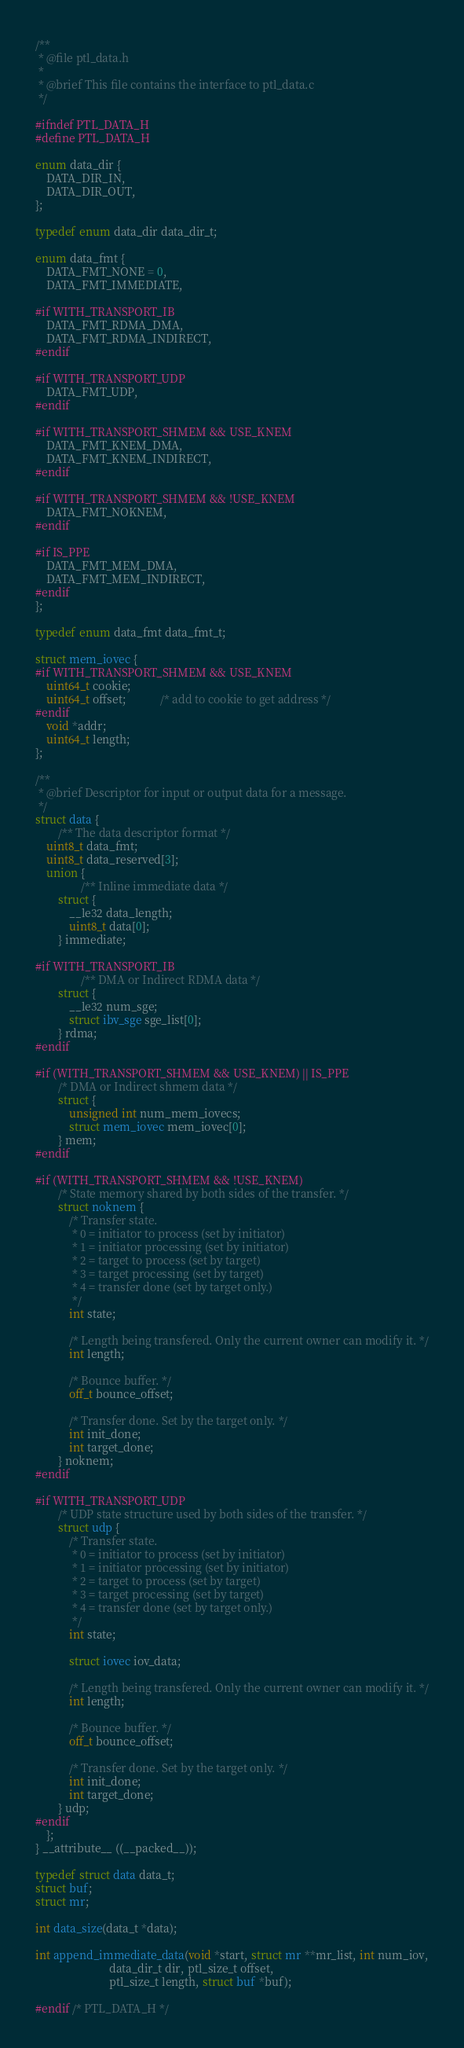Convert code to text. <code><loc_0><loc_0><loc_500><loc_500><_C_>/**
 * @file ptl_data.h
 *
 * @brief This file contains the interface to ptl_data.c
 */

#ifndef PTL_DATA_H
#define PTL_DATA_H

enum data_dir {
    DATA_DIR_IN,
    DATA_DIR_OUT,
};

typedef enum data_dir data_dir_t;

enum data_fmt {
    DATA_FMT_NONE = 0,
    DATA_FMT_IMMEDIATE,

#if WITH_TRANSPORT_IB
    DATA_FMT_RDMA_DMA,
    DATA_FMT_RDMA_INDIRECT,
#endif

#if WITH_TRANSPORT_UDP
    DATA_FMT_UDP,
#endif

#if WITH_TRANSPORT_SHMEM && USE_KNEM
    DATA_FMT_KNEM_DMA,
    DATA_FMT_KNEM_INDIRECT,
#endif

#if WITH_TRANSPORT_SHMEM && !USE_KNEM
    DATA_FMT_NOKNEM,
#endif

#if IS_PPE
    DATA_FMT_MEM_DMA,
    DATA_FMT_MEM_INDIRECT,
#endif
};

typedef enum data_fmt data_fmt_t;

struct mem_iovec {
#if WITH_TRANSPORT_SHMEM && USE_KNEM
    uint64_t cookie;
    uint64_t offset;            /* add to cookie to get address */
#endif
    void *addr;
    uint64_t length;
};

/**
 * @brief Descriptor for input or output data for a message.
 */
struct data {
        /** The data descriptor format */
    uint8_t data_fmt;
    uint8_t data_reserved[3];
    union {
                /** Inline immediate data */
        struct {
            __le32 data_length;
            uint8_t data[0];
        } immediate;

#if WITH_TRANSPORT_IB
                /** DMA or Indirect RDMA data */
        struct {
            __le32 num_sge;
            struct ibv_sge sge_list[0];
        } rdma;
#endif

#if (WITH_TRANSPORT_SHMEM && USE_KNEM) || IS_PPE
        /* DMA or Indirect shmem data */
        struct {
            unsigned int num_mem_iovecs;
            struct mem_iovec mem_iovec[0];
        } mem;
#endif

#if (WITH_TRANSPORT_SHMEM && !USE_KNEM)
        /* State memory shared by both sides of the transfer. */
        struct noknem {
            /* Transfer state.
             * 0 = initiator to process (set by initiator)
             * 1 = initiator processing (set by initiator)
             * 2 = target to process (set by target)
             * 3 = target processing (set by target)
             * 4 = transfer done (set by target only.)
             */
            int state;

            /* Length being transfered. Only the current owner can modify it. */
            int length;

            /* Bounce buffer. */
            off_t bounce_offset;

            /* Transfer done. Set by the target only. */
            int init_done;
            int target_done;
        } noknem;
#endif

#if WITH_TRANSPORT_UDP
        /* UDP state structure used by both sides of the transfer. */
        struct udp {
            /* Transfer state.
             * 0 = initiator to process (set by initiator)
             * 1 = initiator processing (set by initiator)
             * 2 = target to process (set by target)
             * 3 = target processing (set by target)
             * 4 = transfer done (set by target only.)
             */
            int state;

            struct iovec iov_data;

            /* Length being transfered. Only the current owner can modify it. */
            int length;

            /* Bounce buffer. */
            off_t bounce_offset;

            /* Transfer done. Set by the target only. */
            int init_done;
            int target_done;
        } udp;
#endif
    };
} __attribute__ ((__packed__));

typedef struct data data_t;
struct buf;
struct mr;

int data_size(data_t *data);

int append_immediate_data(void *start, struct mr **mr_list, int num_iov,
                          data_dir_t dir, ptl_size_t offset,
                          ptl_size_t length, struct buf *buf);

#endif /* PTL_DATA_H */
</code> 